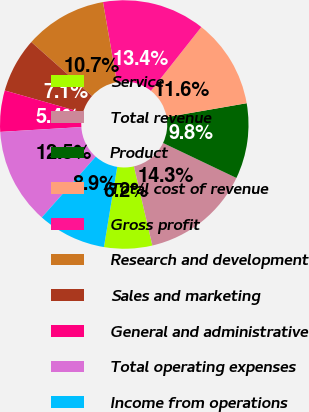Convert chart. <chart><loc_0><loc_0><loc_500><loc_500><pie_chart><fcel>Service<fcel>Total revenue<fcel>Product<fcel>Total cost of revenue<fcel>Gross profit<fcel>Research and development<fcel>Sales and marketing<fcel>General and administrative<fcel>Total operating expenses<fcel>Income from operations<nl><fcel>6.25%<fcel>14.29%<fcel>9.82%<fcel>11.61%<fcel>13.39%<fcel>10.71%<fcel>7.14%<fcel>5.36%<fcel>12.5%<fcel>8.93%<nl></chart> 